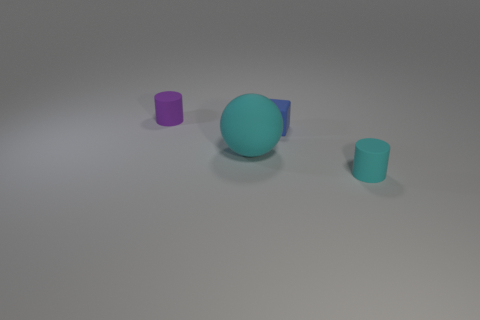The ball has what color?
Your answer should be compact. Cyan. There is a cyan matte thing left of the small cyan matte thing; what shape is it?
Give a very brief answer. Sphere. Are there any large cyan spheres that are to the right of the matte cylinder that is left of the rubber cylinder on the right side of the purple matte thing?
Give a very brief answer. Yes. Is there any other thing that has the same shape as the big cyan thing?
Provide a short and direct response. No. Is there a ball?
Make the answer very short. Yes. There is a cyan thing that is behind the rubber cylinder that is to the right of the rubber cylinder to the left of the big object; what is its size?
Your response must be concise. Large. What number of big things are made of the same material as the tiny purple object?
Your answer should be compact. 1. Is the number of small gray matte balls less than the number of big matte objects?
Provide a short and direct response. Yes. Are the tiny cylinder that is right of the small purple matte thing and the blue cube made of the same material?
Your answer should be compact. Yes. Do the purple thing and the tiny cyan object have the same shape?
Offer a very short reply. Yes. 